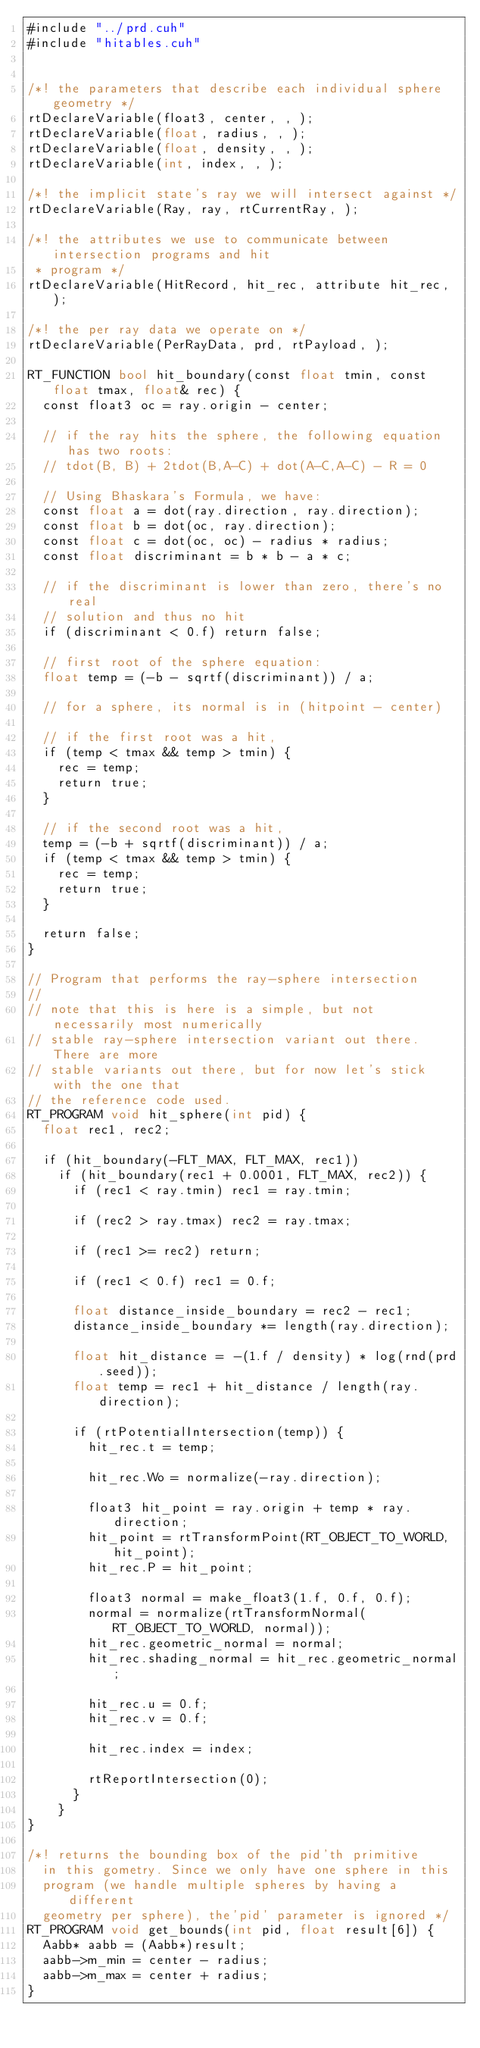Convert code to text. <code><loc_0><loc_0><loc_500><loc_500><_Cuda_>#include "../prd.cuh"
#include "hitables.cuh"


/*! the parameters that describe each individual sphere geometry */
rtDeclareVariable(float3, center, , );
rtDeclareVariable(float, radius, , );
rtDeclareVariable(float, density, , );
rtDeclareVariable(int, index, , );

/*! the implicit state's ray we will intersect against */
rtDeclareVariable(Ray, ray, rtCurrentRay, );

/*! the attributes we use to communicate between intersection programs and hit
 * program */
rtDeclareVariable(HitRecord, hit_rec, attribute hit_rec, );

/*! the per ray data we operate on */
rtDeclareVariable(PerRayData, prd, rtPayload, );

RT_FUNCTION bool hit_boundary(const float tmin, const float tmax, float& rec) {
  const float3 oc = ray.origin - center;

  // if the ray hits the sphere, the following equation has two roots:
  // tdot(B, B) + 2tdot(B,A-C) + dot(A-C,A-C) - R = 0

  // Using Bhaskara's Formula, we have:
  const float a = dot(ray.direction, ray.direction);
  const float b = dot(oc, ray.direction);
  const float c = dot(oc, oc) - radius * radius;
  const float discriminant = b * b - a * c;

  // if the discriminant is lower than zero, there's no real
  // solution and thus no hit
  if (discriminant < 0.f) return false;

  // first root of the sphere equation:
  float temp = (-b - sqrtf(discriminant)) / a;

  // for a sphere, its normal is in (hitpoint - center)

  // if the first root was a hit,
  if (temp < tmax && temp > tmin) {
    rec = temp;
    return true;
  }

  // if the second root was a hit,
  temp = (-b + sqrtf(discriminant)) / a;
  if (temp < tmax && temp > tmin) {
    rec = temp;
    return true;
  }

  return false;
}

// Program that performs the ray-sphere intersection
//
// note that this is here is a simple, but not necessarily most numerically
// stable ray-sphere intersection variant out there. There are more
// stable variants out there, but for now let's stick with the one that
// the reference code used.
RT_PROGRAM void hit_sphere(int pid) {
  float rec1, rec2;

  if (hit_boundary(-FLT_MAX, FLT_MAX, rec1))
    if (hit_boundary(rec1 + 0.0001, FLT_MAX, rec2)) {
      if (rec1 < ray.tmin) rec1 = ray.tmin;

      if (rec2 > ray.tmax) rec2 = ray.tmax;

      if (rec1 >= rec2) return;

      if (rec1 < 0.f) rec1 = 0.f;

      float distance_inside_boundary = rec2 - rec1;
      distance_inside_boundary *= length(ray.direction);

      float hit_distance = -(1.f / density) * log(rnd(prd.seed));
      float temp = rec1 + hit_distance / length(ray.direction);

      if (rtPotentialIntersection(temp)) {
        hit_rec.t = temp;

        hit_rec.Wo = normalize(-ray.direction);

        float3 hit_point = ray.origin + temp * ray.direction;
        hit_point = rtTransformPoint(RT_OBJECT_TO_WORLD, hit_point);
        hit_rec.P = hit_point;

        float3 normal = make_float3(1.f, 0.f, 0.f);
        normal = normalize(rtTransformNormal(RT_OBJECT_TO_WORLD, normal));
        hit_rec.geometric_normal = normal;
        hit_rec.shading_normal = hit_rec.geometric_normal;

        hit_rec.u = 0.f;
        hit_rec.v = 0.f;

        hit_rec.index = index;

        rtReportIntersection(0);
      }
    }
}

/*! returns the bounding box of the pid'th primitive
  in this gometry. Since we only have one sphere in this
  program (we handle multiple spheres by having a different
  geometry per sphere), the'pid' parameter is ignored */
RT_PROGRAM void get_bounds(int pid, float result[6]) {
  Aabb* aabb = (Aabb*)result;
  aabb->m_min = center - radius;
  aabb->m_max = center + radius;
}
</code> 